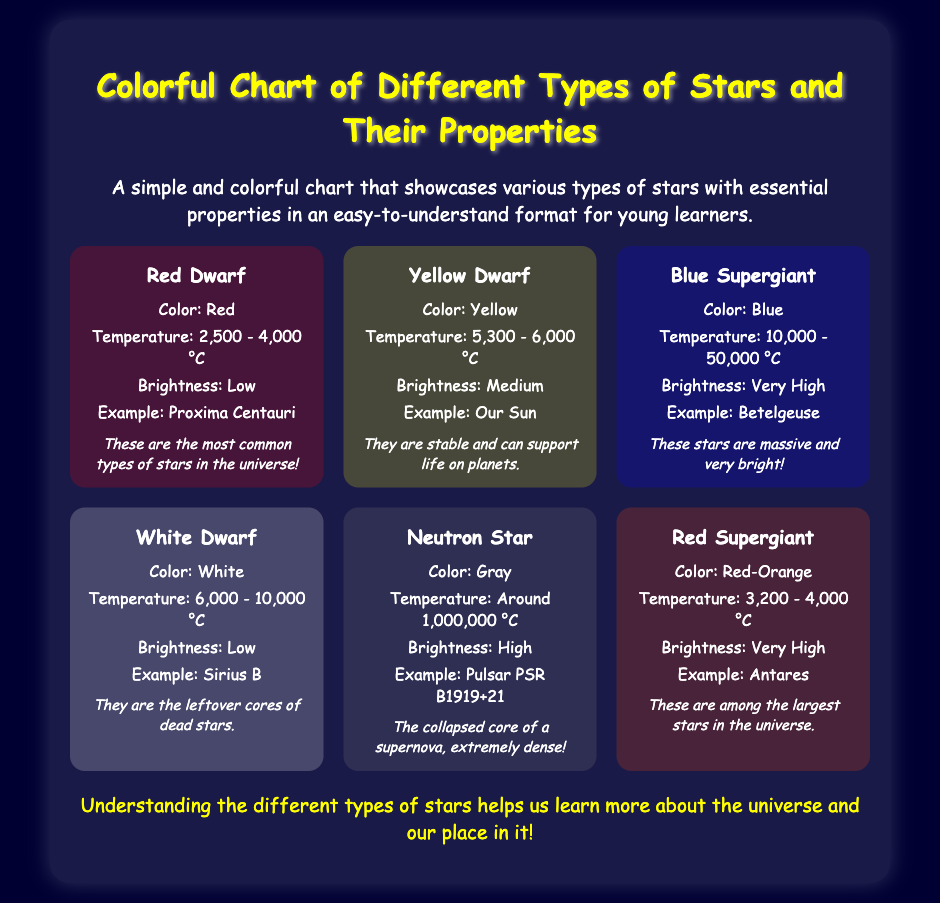What is the color of a Red Dwarf star? The color of a Red Dwarf star, as stated in the document, is Red.
Answer: Red What star type is our Sun? The document mentions that our Sun is an example of a Yellow Dwarf star.
Answer: Yellow Dwarf What is the temperature range of a Blue Supergiant star? According to the document, the temperature range of a Blue Supergiant star is 10,000 - 50,000 °C.
Answer: 10,000 - 50,000 °C Which star is the example of a Neutron Star? The document provides "Pulsar PSR B1919+21" as an example of a Neutron Star.
Answer: Pulsar PSR B1919+21 How bright are Red Supergiant stars? The document states that Red Supergiant stars have Very High brightness.
Answer: Very High What is the main property of White Dwarf stars mentioned in the note? The note indicates that White Dwarf stars are the leftover cores of dead stars.
Answer: Leftover cores of dead stars Why are Yellow Dwarf stars important? The document notes that Yellow Dwarf stars can support life on planets.
Answer: Support life on planets What color is associated with Red Supergiant stars? The document specifies Red-Orange as the color associated with Red Supergiant stars.
Answer: Red-Orange How many star types are shown in the colorful chart? The document displays a total of six different star types.
Answer: Six 